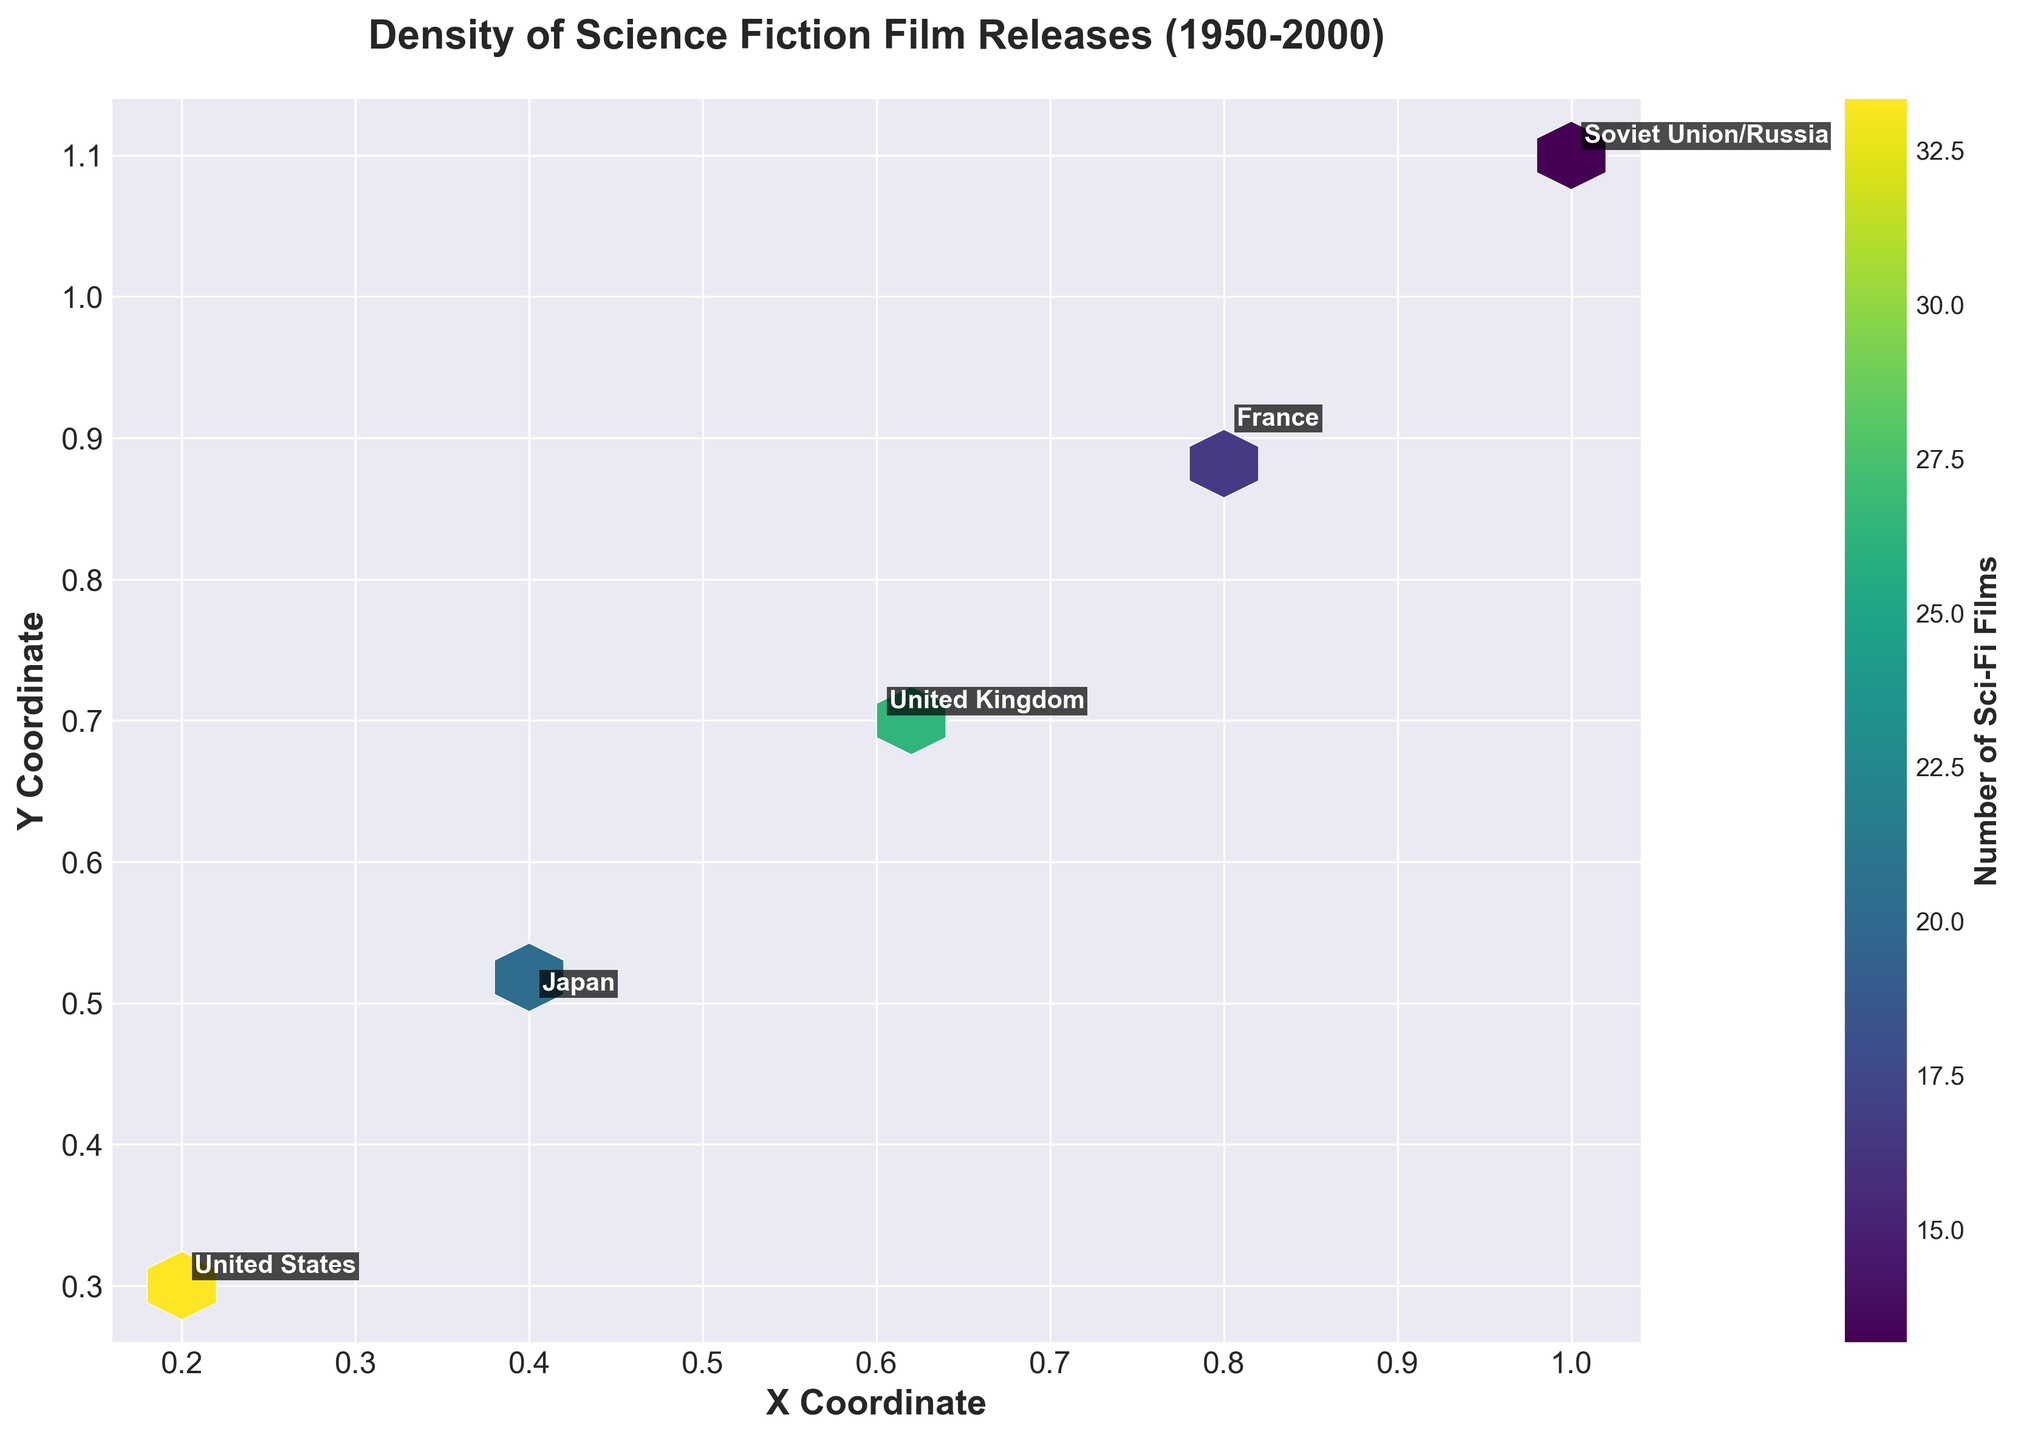Which country shows the highest density of science fiction film releases? The highest density can be identified by the hexbin plot's color intensity. By observing the most intense color (representing the highest density), it appears that the United States shows the highest density with 62 films counted in 2000.
Answer: United States Which country had the lowest number of science fiction film releases in 1950? By looking at the annotated countries and the least intense color (the lowest film count), the Soviet Union/Russia had the lowest count with 2 films in 1950.
Answer: Soviet Union/Russia How does the density of science fiction film releases in 2000 for the United Kingdom compare to Japan? By comparing the color intensities of the hexbins where the United Kingdom and Japan are annotated, the United Kingdom has a higher density with 50 films compared to Japan's 40 films in 2000.
Answer: United Kingdom has higher density What trend do you see in the number of science fiction film releases in France from 1950 to 2000? By observing the color changes and the annotation of France over time, we can see a steady increase from 3 films in 1950 to 35 films in 2000, indicating a growing trend in science fiction film production.
Answer: Increasing trend Which country experienced the largest increase in science fiction film releases from 1950 to 2000? Calculating the difference for each country: United States (62-12 = 50), Japan (40-5 = 35), United Kingdom (50-8 = 42), France (35-3 = 32), and Soviet Union/Russia (28-2 = 26), the United States shows the largest increase with 50 additional films.
Answer: United States What is the distribution pattern of hexbin colors in the plot? The plot shows a distribution pattern where darker colors (higher densities) are more central, especially for the United States, and lighter colors are more spread out for other countries, representing lower densities.
Answer: Dark colors centrally concentrated How does the release density of science fiction films in Japan in the 1990s compare to the Soviet Union/Russia in the same decade? By comparing the color intensity of the hexbins for Japan and the Soviet Union/Russia in the 1990s, Japan shows a higher density with 30 films while Soviet Union/Russia has a density of 20 films.
Answer: Japan has higher density What does the color bar in the plot represent? The color bar indicates the number of science fiction films, with colors ranging from lighter tones (lower numbers) to darker tones (higher numbers).
Answer: Number of Sci-Fi films Which country shows a notable increase in the density of science fiction film releases starting from the 1980s? Observing the color progression for each country, the United States shows a significant increase starting from the 1980s, moving from a moderate density to the highest by 2000.
Answer: United States 